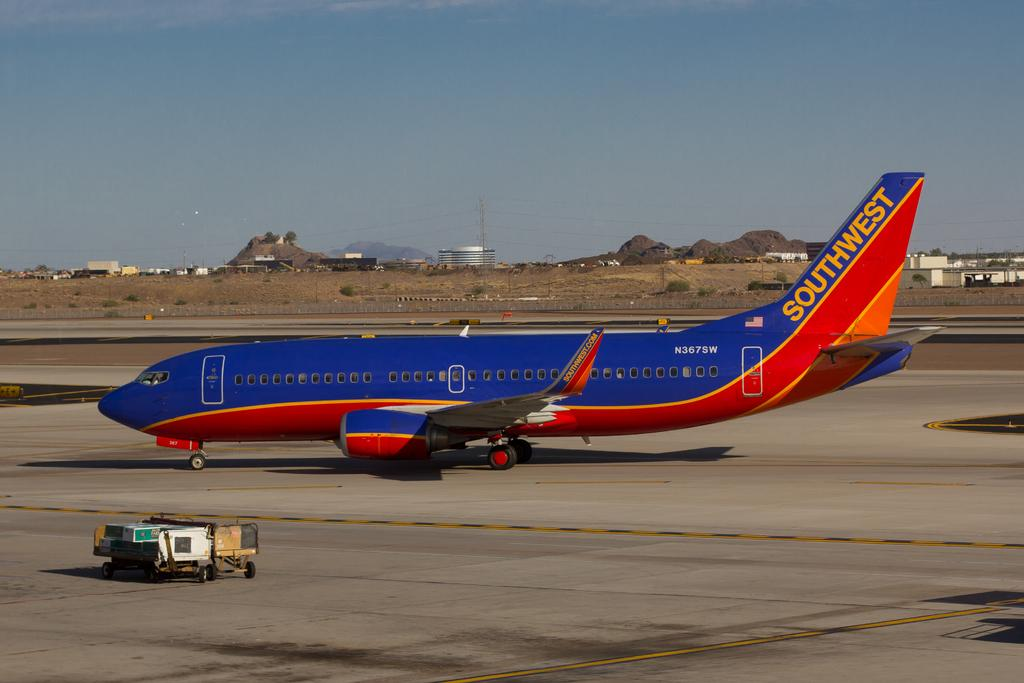What type of surface can be seen in the image? There is ground visible in the image. What mode of transportation is present in the image? There is an air craft in the image. What object is used for transporting items in the image? There is a trolley with objects in the image. What natural features are visible in the image? There are mountains and trees in the image. What man-made structures are visible in the image? There are buildings, poles, and containers in the image. What part of the natural environment is visible in the image? The sky is visible in the image. What is the smell of the volleyball in the image? There is no volleyball present in the image, so it is not possible to determine its smell. What shape is the square in the image? There is no square present in the image. 